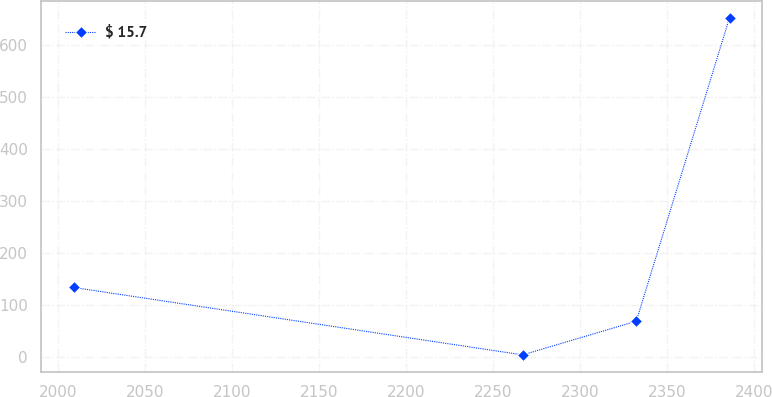Convert chart. <chart><loc_0><loc_0><loc_500><loc_500><line_chart><ecel><fcel>$ 15.7<nl><fcel>2008.96<fcel>133.37<nl><fcel>2266.92<fcel>3.75<nl><fcel>2332.23<fcel>68.56<nl><fcel>2385.8<fcel>651.89<nl></chart> 